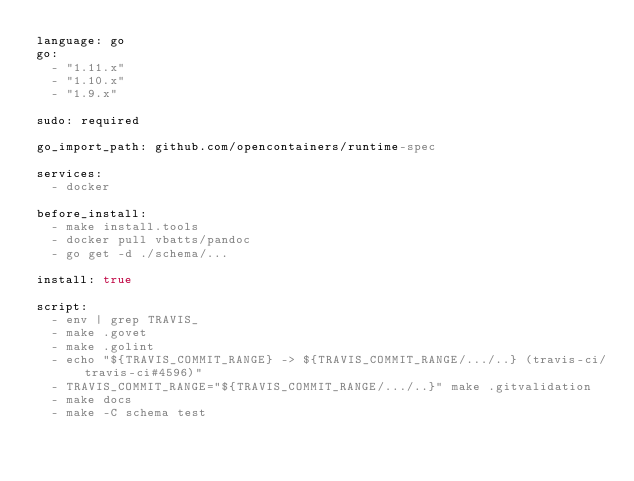Convert code to text. <code><loc_0><loc_0><loc_500><loc_500><_YAML_>language: go
go:
  - "1.11.x"
  - "1.10.x"
  - "1.9.x"

sudo: required

go_import_path: github.com/opencontainers/runtime-spec

services:
  - docker

before_install:
  - make install.tools
  - docker pull vbatts/pandoc
  - go get -d ./schema/...

install: true

script:
  - env | grep TRAVIS_
  - make .govet
  - make .golint
  - echo "${TRAVIS_COMMIT_RANGE} -> ${TRAVIS_COMMIT_RANGE/.../..} (travis-ci/travis-ci#4596)"
  - TRAVIS_COMMIT_RANGE="${TRAVIS_COMMIT_RANGE/.../..}" make .gitvalidation
  - make docs
  - make -C schema test
</code> 